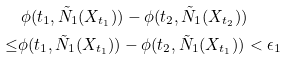<formula> <loc_0><loc_0><loc_500><loc_500>& \, \phi ( t _ { 1 } , \tilde { N } _ { 1 } ( X _ { t _ { 1 } } ) ) - \phi ( t _ { 2 } , \tilde { N } _ { 1 } ( X _ { t _ { 2 } } ) ) \\ \quad \leq & \phi ( t _ { 1 } , \tilde { N } _ { 1 } ( X _ { t _ { 1 } } ) ) - \phi ( t _ { 2 } , \tilde { N } _ { 1 } ( X _ { t _ { 1 } } ) ) < \epsilon _ { 1 }</formula> 